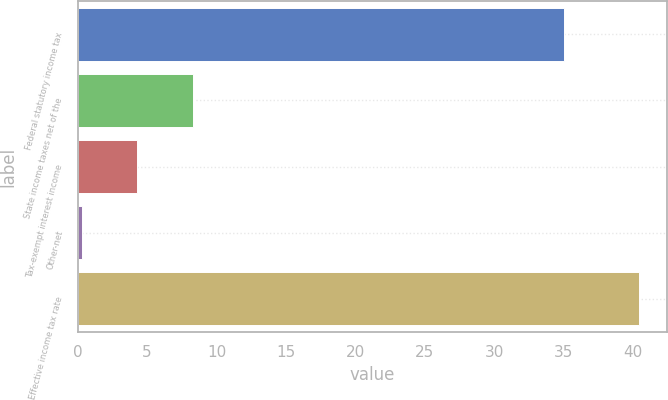<chart> <loc_0><loc_0><loc_500><loc_500><bar_chart><fcel>Federal statutory income tax<fcel>State income taxes net of the<fcel>Tax-exempt interest income<fcel>Other-net<fcel>Effective income tax rate<nl><fcel>35<fcel>8.32<fcel>4.31<fcel>0.3<fcel>40.4<nl></chart> 